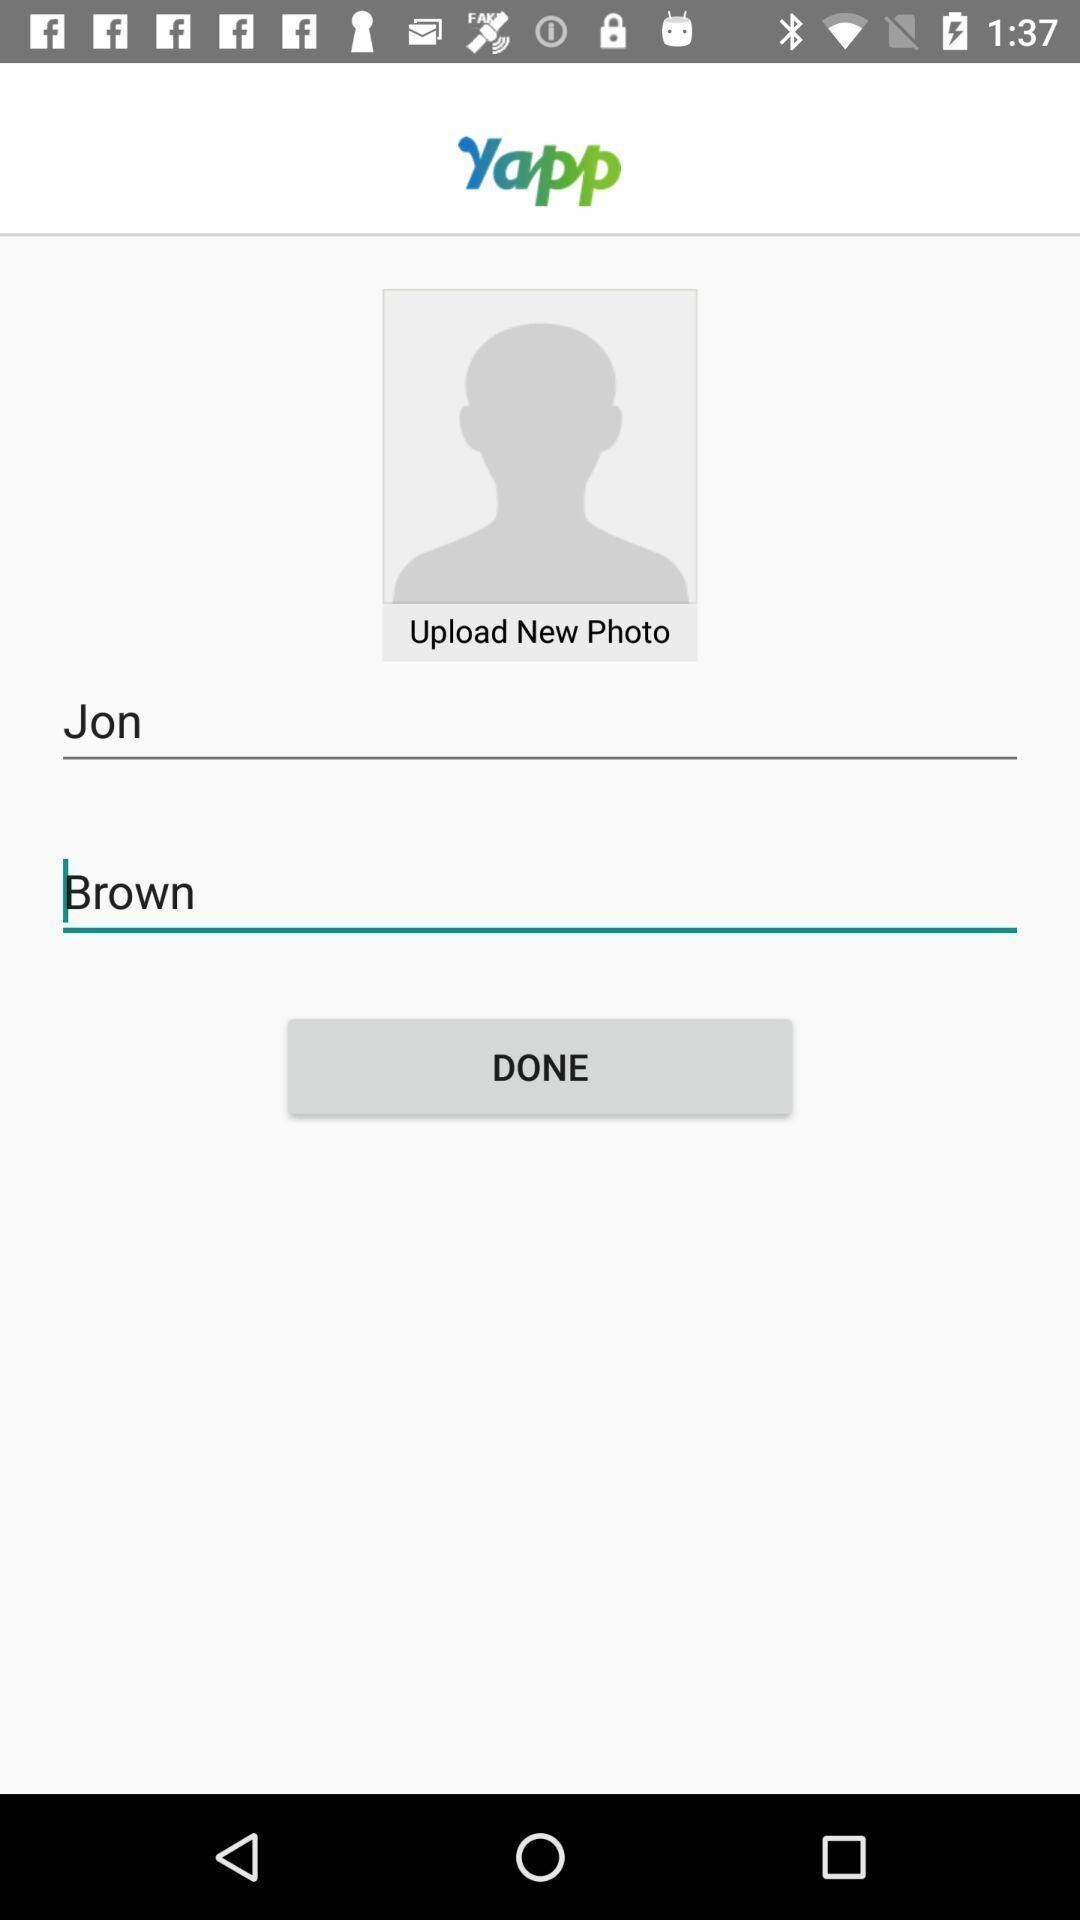Explain what's happening in this screen capture. Screen showing profile upload page of a social app. 